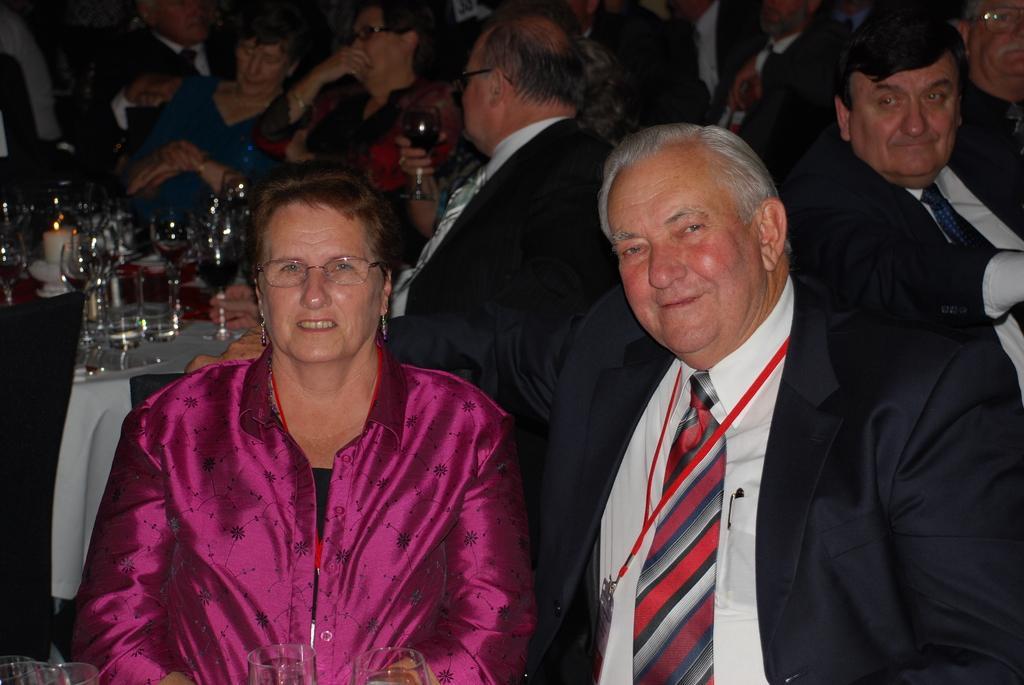In one or two sentences, can you explain what this image depicts? In the picture I can see so many people are sitting in front of the table, on the table we can see so many glasses and some objects. 